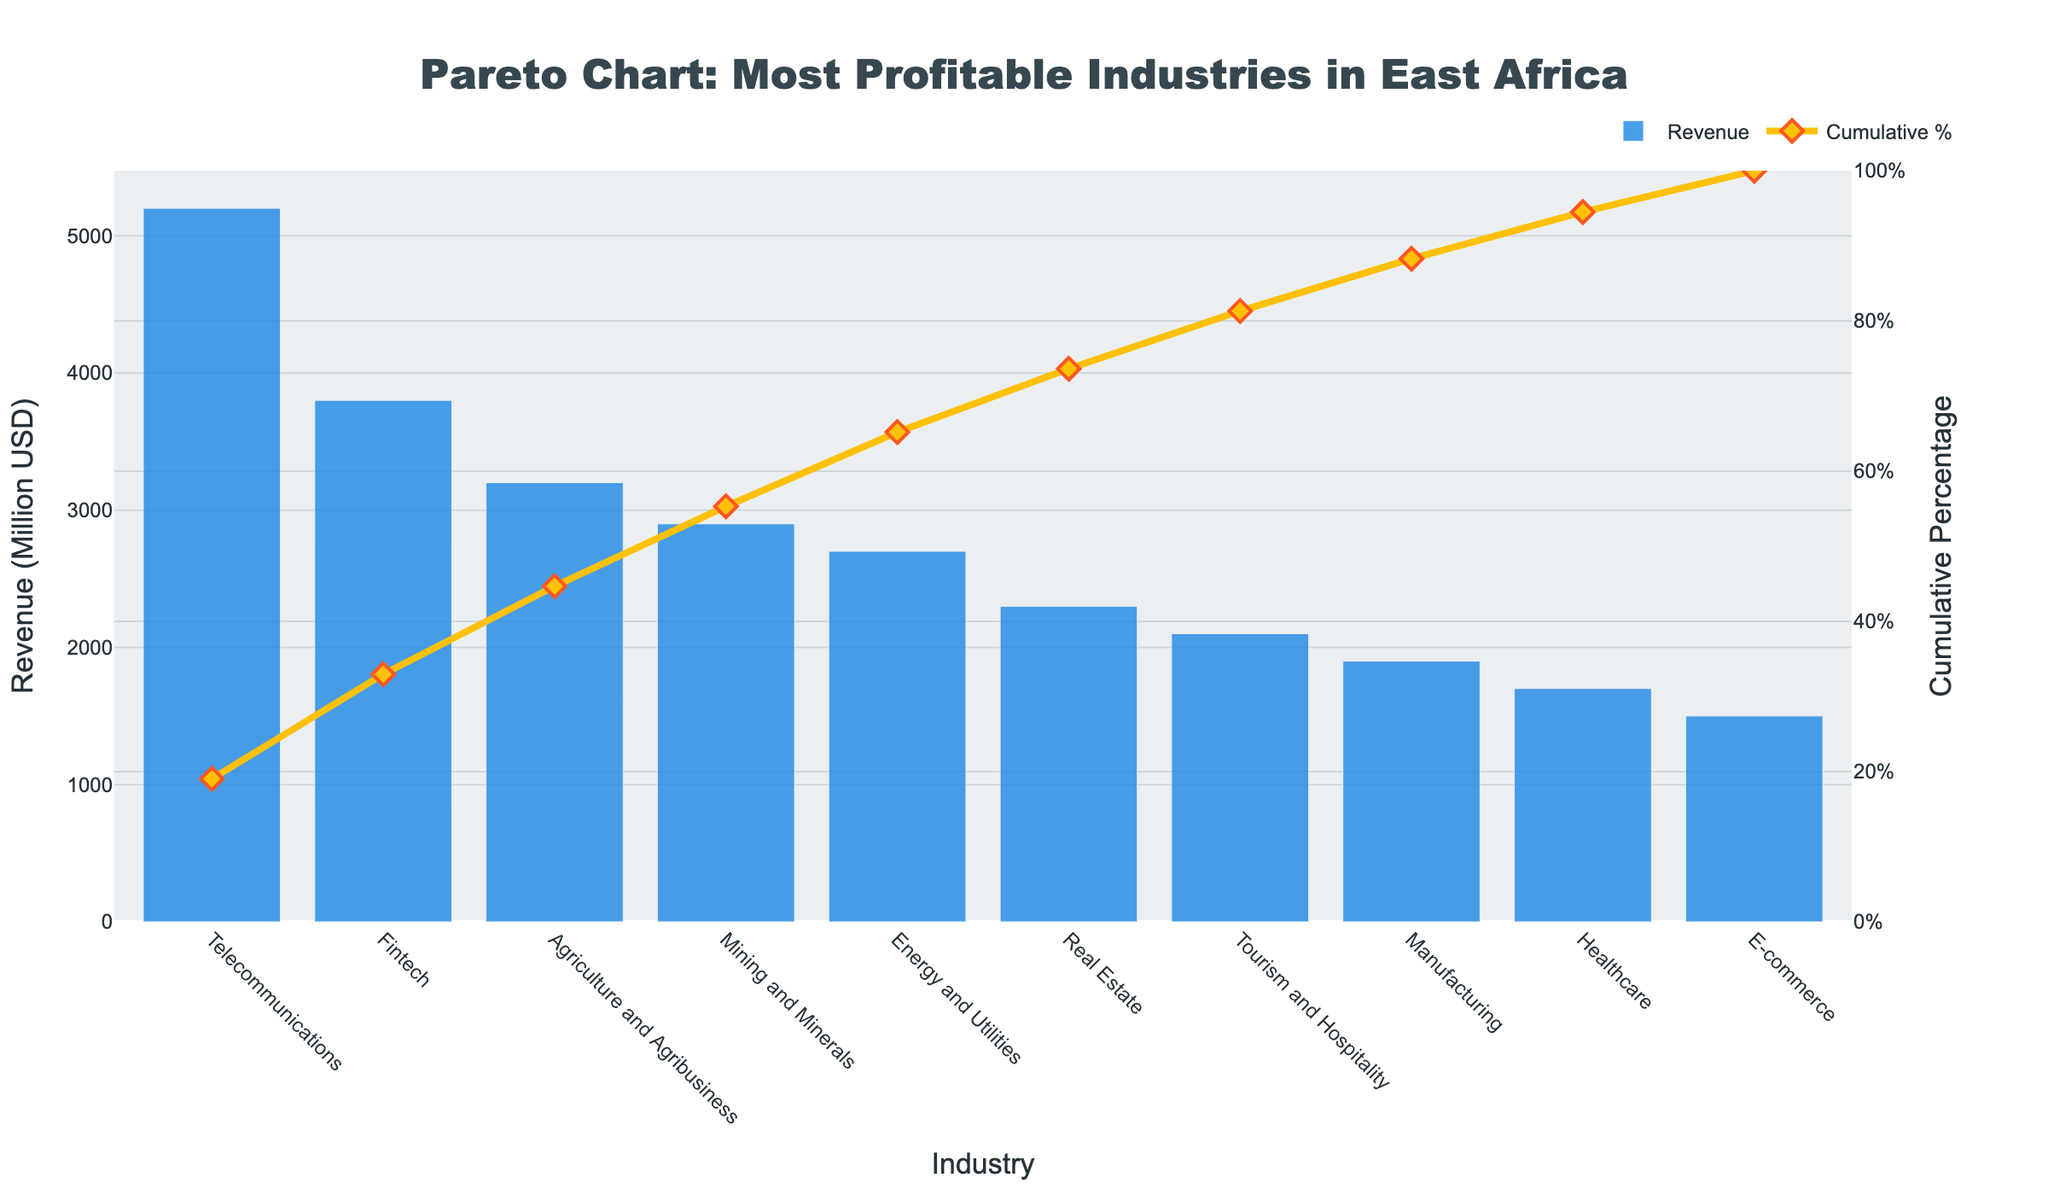what is the total revenue represented in the chart? To find the total revenue represented in the chart, add up the revenue of all industries shown: 5200 + 3800 + 3200 + 2900 + 2700 + 2300 + 2100 + 1900 + 1700 + 1500 = 27300 million USD
Answer: 27300 million USD Which industry has the highest profit margin? The industry with the highest profit margin can be identified by checking the given data table for the highest profit margin value. Fintech has the highest profit margin at 22.3%.
Answer: Fintech What is the cumulative percentage for the top three industries by revenue? The cumulative percentage for the top three industries is represented by the 'Cumulative Percentage' line on the secondary y-axis. Check the cumulative percentages for Telecommunications, Fintech, and Agriculture and Agribusiness from the chart. It should be around the values next to those points.
Answer: ~ 46.5% Which industry has the lowest revenue represented in the chart? The industry with the lowest revenue can be identified by checking the bar chart for the shortest bar. The shortest bar represents the E-commerce industry, with a revenue of 1500 million USD.
Answer: E-commerce What's the revenue difference between the industry with the highest revenue and the one with the lowest revenue? The revenue difference between Telecommunications (highest) and E-commerce (lowest) can be calculated as follows: 5200 - 1500 = 3700 million USD.
Answer: 3700 million USD What is the cumulative percentage for Real Estate? Find Real Estate on the x-axis and trace the Cumulative Percentage line to its value on the secondary y-axis. This corresponds to the point where Real Estate is represented.
Answer: ~ 67.4% Which two industries, if combined, would surpass the halfway mark (50%) of the total revenue? We need to check the cumulative percentages till we find two industries whose cumulative sum crosses 50%. Telecommunications (19.0%) + Fintech (33.9%) add up to more than 50%.
Answer: Telecommunications and Fintech What is the average profit margin of the top three industries by revenue? From the data, the top three industries by revenue are Telecommunications, Fintech, and Agriculture and Agribusiness. Their profit margins are 18.5%, 22.3%, and 14.7%, respectively. Average = (18.5 + 22.3 + 14.7) / 3 = 18.5%.
Answer: 18.5% Which industries have a profit margin greater than 15%? Check the list of industries and their corresponding profit margins from the data table. The industries with a profit margin greater than 15% are Telecommunications, Fintech, Mining and Minerals, Energy and Utilities, and Real Estate.
Answer: Telecommunications, Fintech, Mining and Minerals, Energy and Utilities, Real Estate How many industries have a cumulative percentage greater than 80%? Check the Cumulative Percentage line on the secondary y-axis and count the number of industries after the 80% mark. The industries surpassing this mark would be those falling after "Manufacturing" in the x-axis.
Answer: 2 